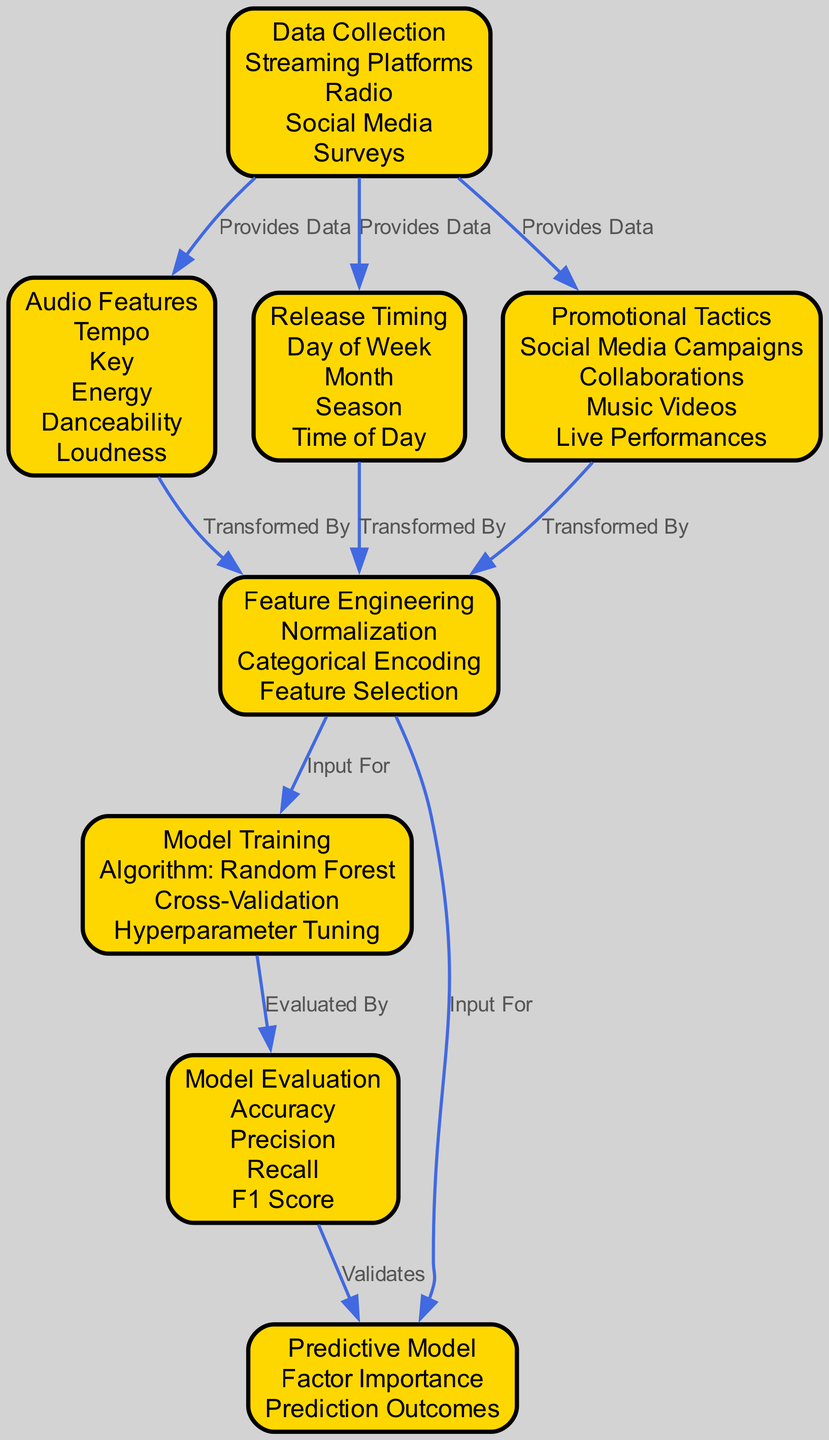What are the audio features identified in the model? The diagram clearly lists the audio features under the "Audio Features" node, which are Tempo, Key, Energy, Danceability, and Loudness.
Answer: Tempo, Key, Energy, Danceability, Loudness How many nodes are present in the diagram? By counting the distinct nodes depicted in the diagram, we find a total of 8 nodes representing various components of the classification model.
Answer: 8 What type of model is being trained? The "Model Training" node indicates that the algorithm used for training is Random Forest.
Answer: Random Forest Which node does "Feature Engineering" receive input from? The "Feature Engineering" node receives input from three nodes: "Audio Features," "Release Timing," and "Promotional Tactics."
Answer: Audio Features, Release Timing, Promotional Tactics How is the model evaluated? The "Model Evaluation" node lists the evaluation metrics as Accuracy, Precision, Recall, and F1 Score, ensuring a comprehensive assessment of the model's performance.
Answer: Accuracy, Precision, Recall, F1 Score What relationship connects "Data Collection" to "Audio Features"? The diagram shows that "Data Collection" provides data to "Audio Features," indicating that data sourced during collection directly informs the audio features analyzed.
Answer: Provides Data Which node ensures inputs for both "Model Training" and "Predictive Model"? The "Feature Engineering" node serves as the input for both "Model Training" and "Predictive Model," highlighting its critical role in the process.
Answer: Feature Engineering What does the "Model Evaluation" node validate? The "Model Evaluation" node is linked to the "Predictive Model" as it validates the outcomes of the model based on various evaluation metrics.
Answer: Validates 